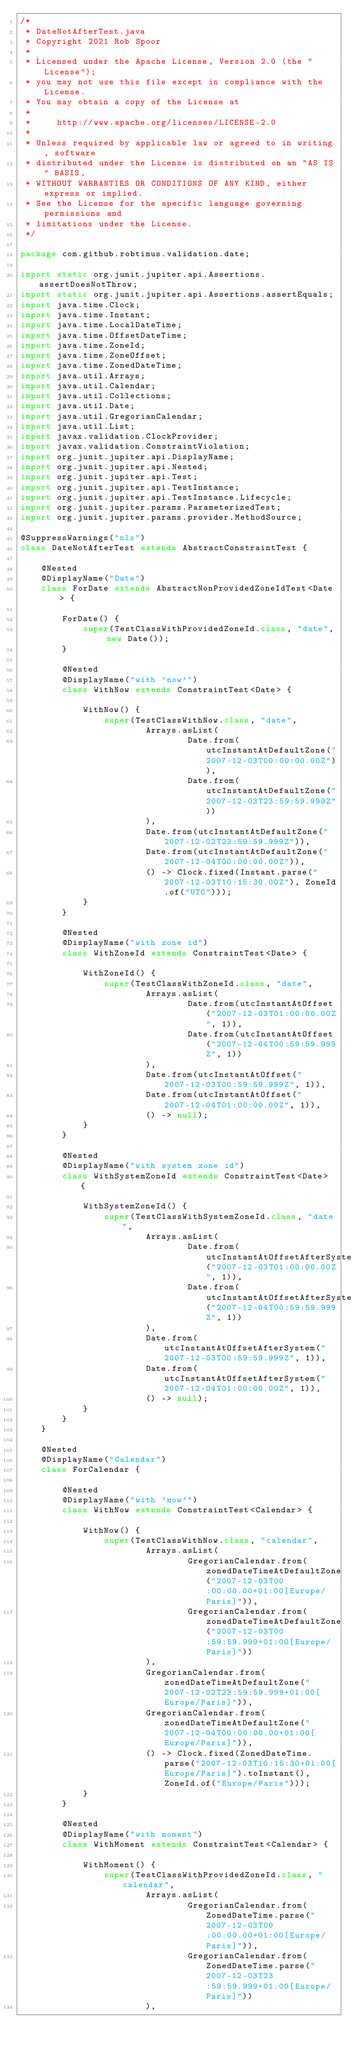Convert code to text. <code><loc_0><loc_0><loc_500><loc_500><_Java_>/*
 * DateNotAfterTest.java
 * Copyright 2021 Rob Spoor
 *
 * Licensed under the Apache License, Version 2.0 (the "License");
 * you may not use this file except in compliance with the License.
 * You may obtain a copy of the License at
 *
 *     http://www.apache.org/licenses/LICENSE-2.0
 *
 * Unless required by applicable law or agreed to in writing, software
 * distributed under the License is distributed on an "AS IS" BASIS,
 * WITHOUT WARRANTIES OR CONDITIONS OF ANY KIND, either express or implied.
 * See the License for the specific language governing permissions and
 * limitations under the License.
 */

package com.github.robtimus.validation.date;

import static org.junit.jupiter.api.Assertions.assertDoesNotThrow;
import static org.junit.jupiter.api.Assertions.assertEquals;
import java.time.Clock;
import java.time.Instant;
import java.time.LocalDateTime;
import java.time.OffsetDateTime;
import java.time.ZoneId;
import java.time.ZoneOffset;
import java.time.ZonedDateTime;
import java.util.Arrays;
import java.util.Calendar;
import java.util.Collections;
import java.util.Date;
import java.util.GregorianCalendar;
import java.util.List;
import javax.validation.ClockProvider;
import javax.validation.ConstraintViolation;
import org.junit.jupiter.api.DisplayName;
import org.junit.jupiter.api.Nested;
import org.junit.jupiter.api.Test;
import org.junit.jupiter.api.TestInstance;
import org.junit.jupiter.api.TestInstance.Lifecycle;
import org.junit.jupiter.params.ParameterizedTest;
import org.junit.jupiter.params.provider.MethodSource;

@SuppressWarnings("nls")
class DateNotAfterTest extends AbstractConstraintTest {

    @Nested
    @DisplayName("Date")
    class ForDate extends AbstractNonProvidedZoneIdTest<Date> {

        ForDate() {
            super(TestClassWithProvidedZoneId.class, "date", new Date());
        }

        @Nested
        @DisplayName("with 'now'")
        class WithNow extends ConstraintTest<Date> {

            WithNow() {
                super(TestClassWithNow.class, "date",
                        Arrays.asList(
                                Date.from(utcInstantAtDefaultZone("2007-12-03T00:00:00.00Z")),
                                Date.from(utcInstantAtDefaultZone("2007-12-03T23:59:59.999Z"))
                        ),
                        Date.from(utcInstantAtDefaultZone("2007-12-02T23:59:59.999Z")),
                        Date.from(utcInstantAtDefaultZone("2007-12-04T00:00:00.00Z")),
                        () -> Clock.fixed(Instant.parse("2007-12-03T10:15:30.00Z"), ZoneId.of("UTC")));
            }
        }

        @Nested
        @DisplayName("with zone id")
        class WithZoneId extends ConstraintTest<Date> {

            WithZoneId() {
                super(TestClassWithZoneId.class, "date",
                        Arrays.asList(
                                Date.from(utcInstantAtOffset("2007-12-03T01:00:00.00Z", 1)),
                                Date.from(utcInstantAtOffset("2007-12-04T00:59:59.999Z", 1))
                        ),
                        Date.from(utcInstantAtOffset("2007-12-03T00:59:59.999Z", 1)),
                        Date.from(utcInstantAtOffset("2007-12-04T01:00:00.00Z", 1)),
                        () -> null);
            }
        }

        @Nested
        @DisplayName("with system zone id")
        class WithSystemZoneId extends ConstraintTest<Date> {

            WithSystemZoneId() {
                super(TestClassWithSystemZoneId.class, "date",
                        Arrays.asList(
                                Date.from(utcInstantAtOffsetAfterSystem("2007-12-03T01:00:00.00Z", 1)),
                                Date.from(utcInstantAtOffsetAfterSystem("2007-12-04T00:59:59.999Z", 1))
                        ),
                        Date.from(utcInstantAtOffsetAfterSystem("2007-12-03T00:59:59.999Z", 1)),
                        Date.from(utcInstantAtOffsetAfterSystem("2007-12-04T01:00:00.00Z", 1)),
                        () -> null);
            }
        }
    }

    @Nested
    @DisplayName("Calendar")
    class ForCalendar {

        @Nested
        @DisplayName("with 'now'")
        class WithNow extends ConstraintTest<Calendar> {

            WithNow() {
                super(TestClassWithNow.class, "calendar",
                        Arrays.asList(
                                GregorianCalendar.from(zonedDateTimeAtDefaultZone("2007-12-03T00:00:00.00+01:00[Europe/Paris]")),
                                GregorianCalendar.from(zonedDateTimeAtDefaultZone("2007-12-03T00:59:59.999+01:00[Europe/Paris]"))
                        ),
                        GregorianCalendar.from(zonedDateTimeAtDefaultZone("2007-12-02T23:59:59.999+01:00[Europe/Paris]")),
                        GregorianCalendar.from(zonedDateTimeAtDefaultZone("2007-12-04T00:00:00.00+01:00[Europe/Paris]")),
                        () -> Clock.fixed(ZonedDateTime.parse("2007-12-03T10:15:30+01:00[Europe/Paris]").toInstant(), ZoneId.of("Europe/Paris")));
            }
        }

        @Nested
        @DisplayName("with moment")
        class WithMoment extends ConstraintTest<Calendar> {

            WithMoment() {
                super(TestClassWithProvidedZoneId.class, "calendar",
                        Arrays.asList(
                                GregorianCalendar.from(ZonedDateTime.parse("2007-12-03T00:00:00.00+01:00[Europe/Paris]")),
                                GregorianCalendar.from(ZonedDateTime.parse("2007-12-03T23:59:59.999+01:00[Europe/Paris]"))
                        ),</code> 